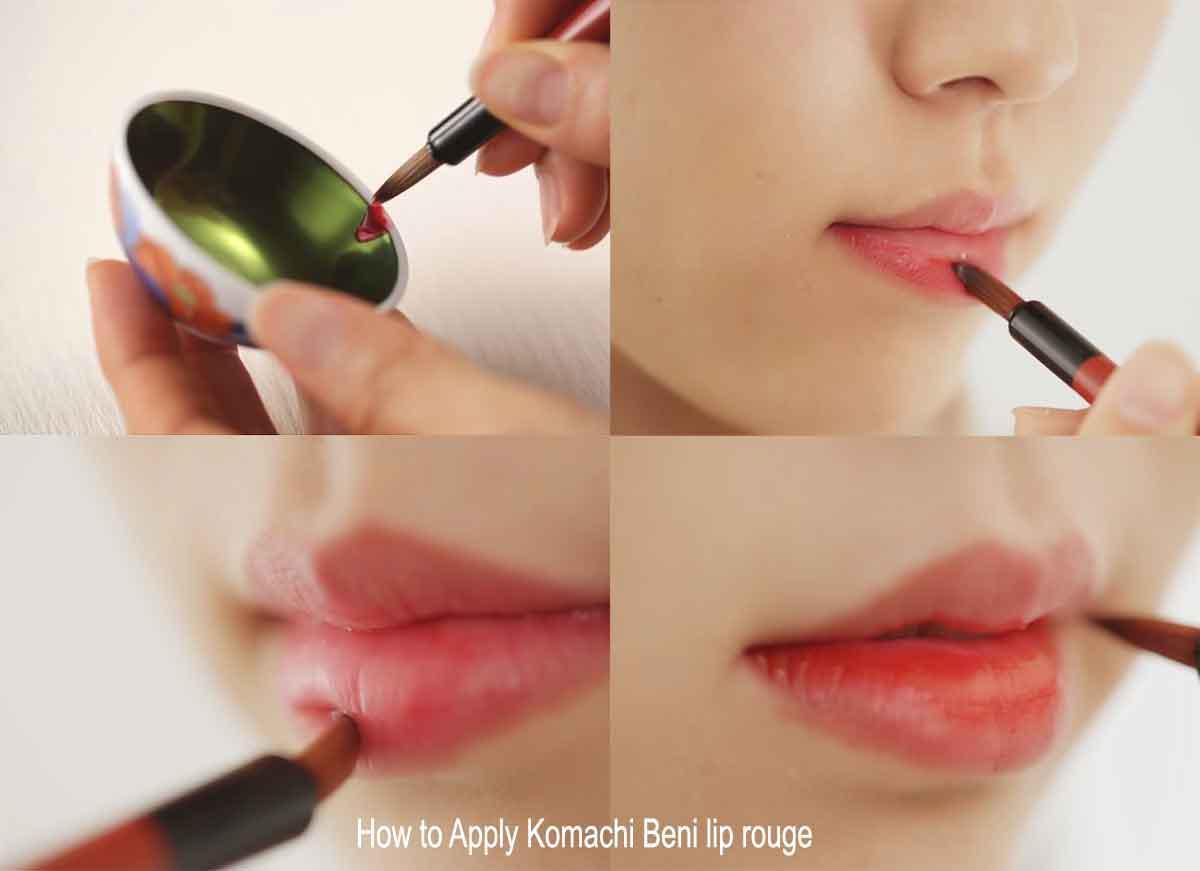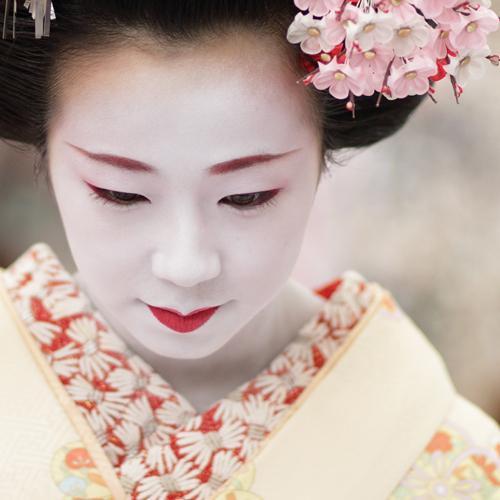The first image is the image on the left, the second image is the image on the right. Examine the images to the left and right. Is the description "A geisha is wearing large flowers on her hair and is not looking at the camera." accurate? Answer yes or no. Yes. The first image is the image on the left, the second image is the image on the right. Examine the images to the left and right. Is the description "An image shows a woman in pale geisha makeup, with pink flowers in her upswept hair." accurate? Answer yes or no. Yes. 